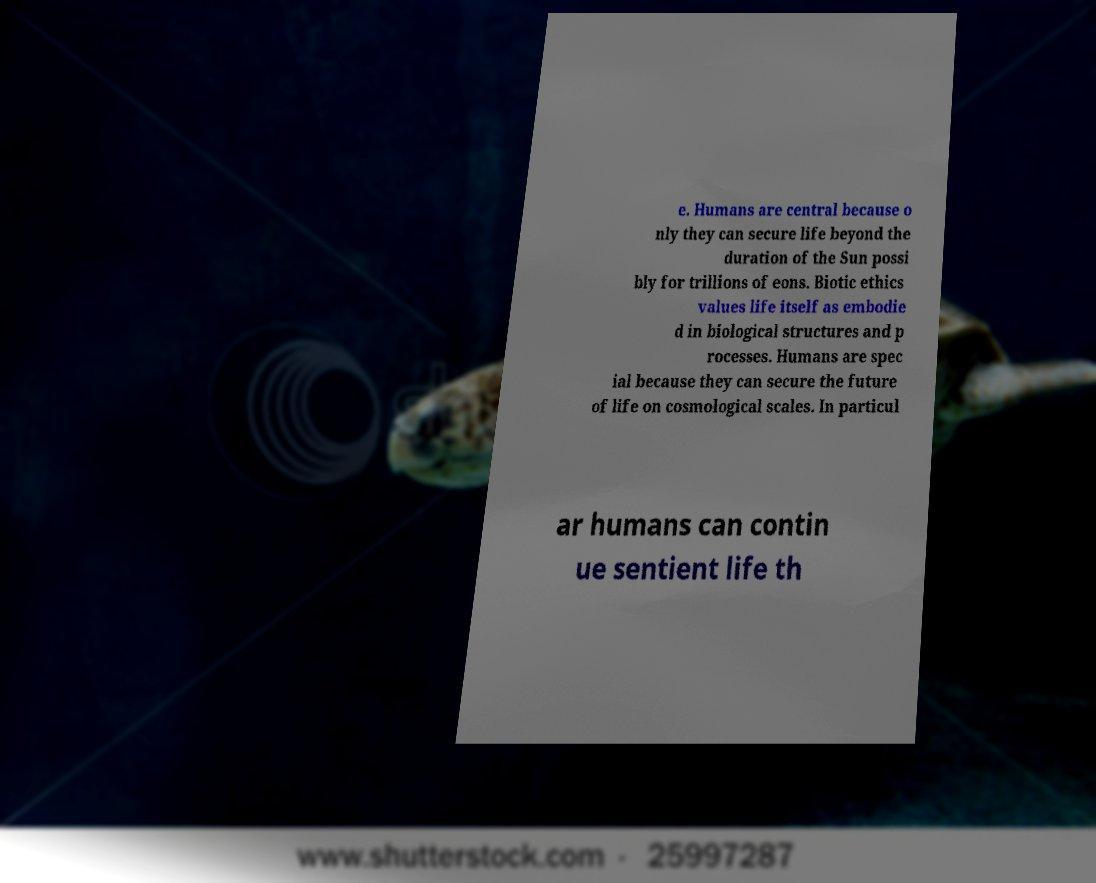Could you extract and type out the text from this image? e. Humans are central because o nly they can secure life beyond the duration of the Sun possi bly for trillions of eons. Biotic ethics values life itself as embodie d in biological structures and p rocesses. Humans are spec ial because they can secure the future of life on cosmological scales. In particul ar humans can contin ue sentient life th 